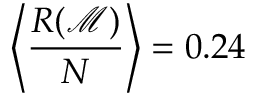Convert formula to latex. <formula><loc_0><loc_0><loc_500><loc_500>\left < \frac { R ( \mathcal { M } ) } { N } \right > = 0 . 2 4</formula> 